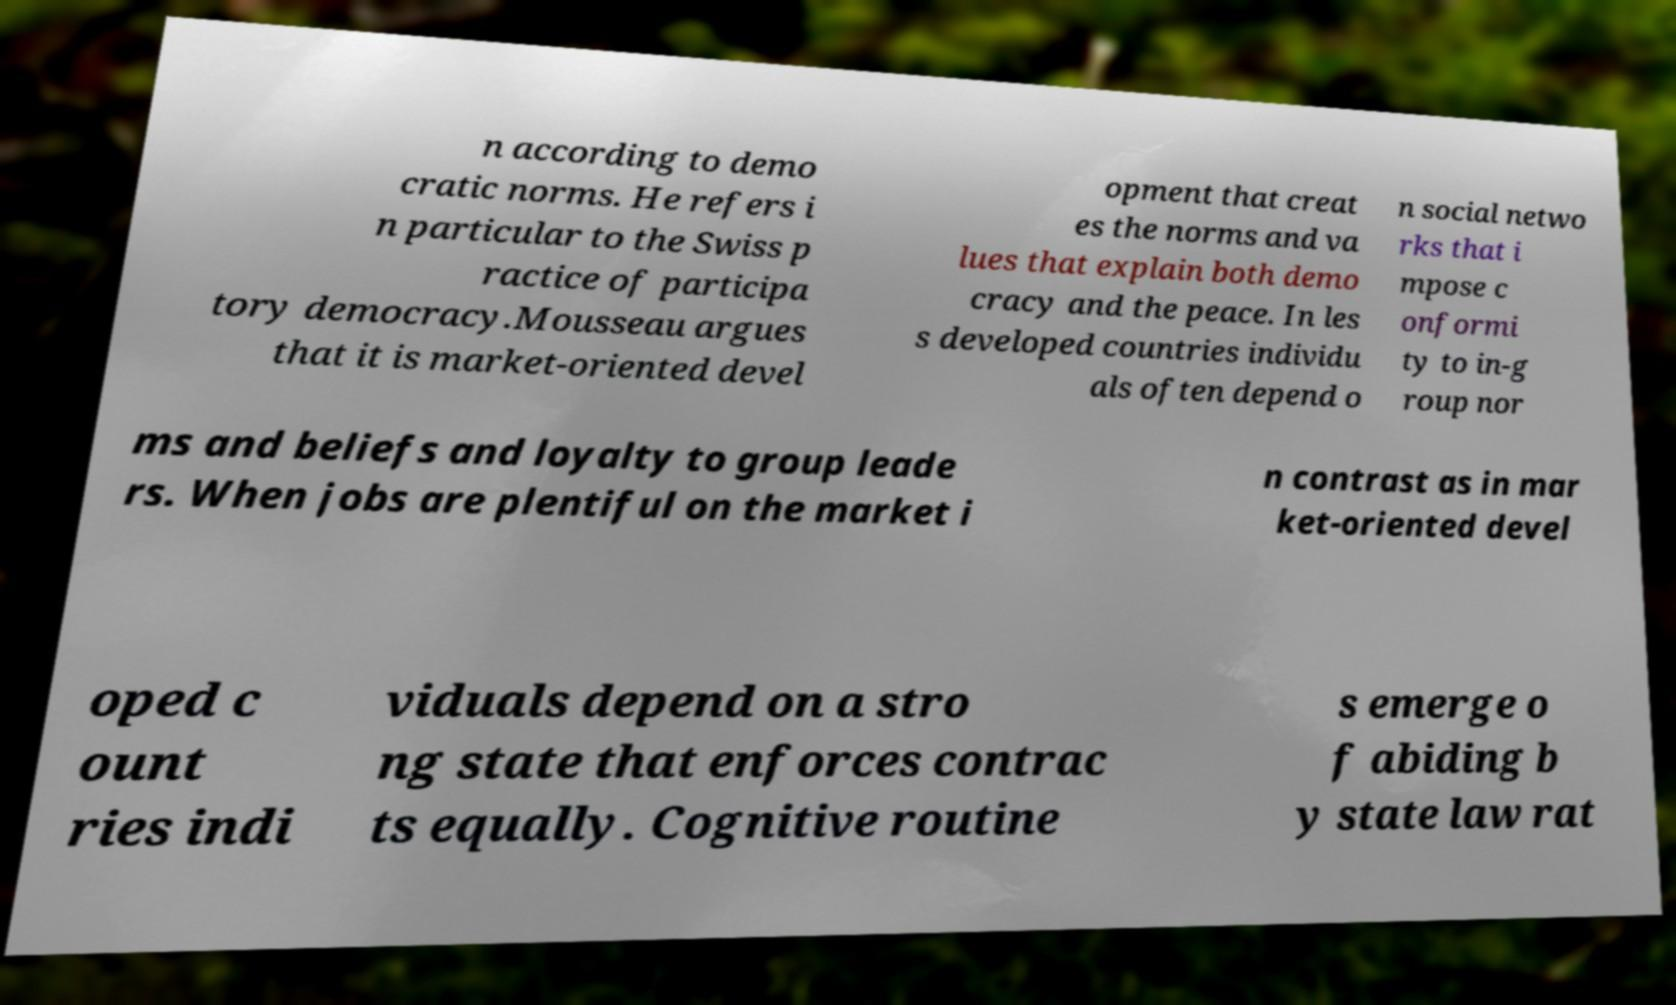Could you extract and type out the text from this image? n according to demo cratic norms. He refers i n particular to the Swiss p ractice of participa tory democracy.Mousseau argues that it is market-oriented devel opment that creat es the norms and va lues that explain both demo cracy and the peace. In les s developed countries individu als often depend o n social netwo rks that i mpose c onformi ty to in-g roup nor ms and beliefs and loyalty to group leade rs. When jobs are plentiful on the market i n contrast as in mar ket-oriented devel oped c ount ries indi viduals depend on a stro ng state that enforces contrac ts equally. Cognitive routine s emerge o f abiding b y state law rat 